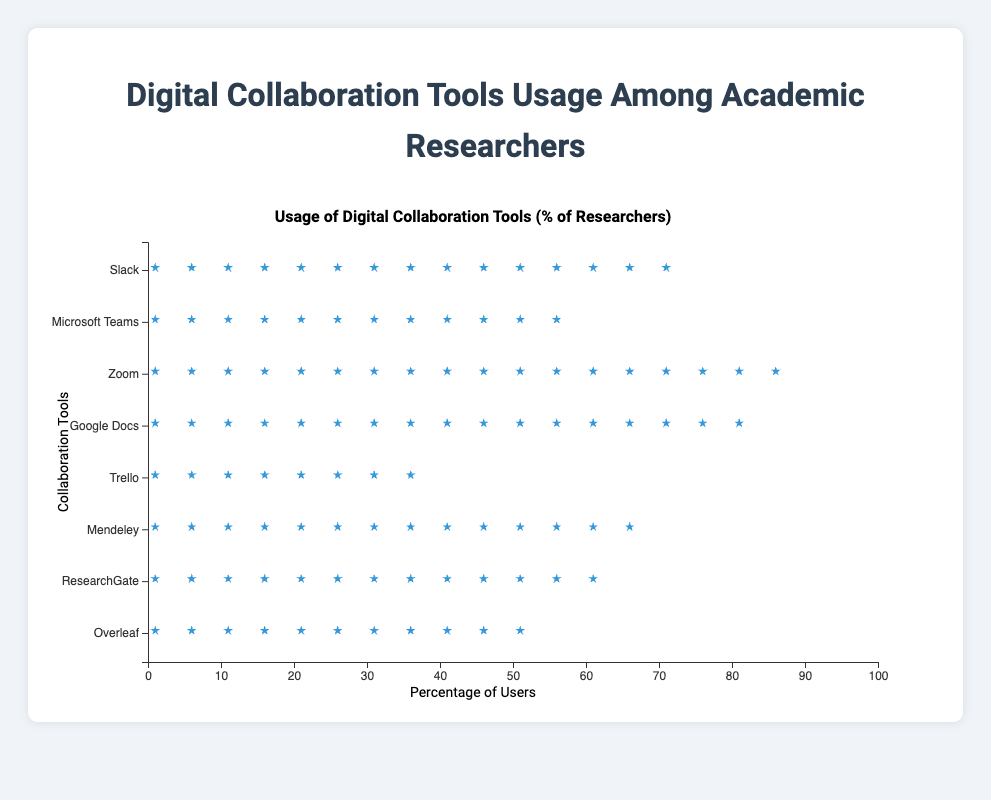What's the most used digital collaboration tool among academic researchers? To answer this, look for the tool with the highest number of icons or the longest row in the plot.
Answer: Zoom What's the least used digital collaboration tool among academic researchers? Identify the tool with the shortest row or the fewest number of icons.
Answer: Trello How many percentage points more researchers use Zoom compared to Trello? Zoom has 90% users and Trello has 40% users. The difference is calculated as 90 - 40.
Answer: 50 Which tool has more users, Microsoft Teams or ResearchGate? Compare the length of the rows or number of icons of both tools.
Answer: ResearchGate By how much does Mendeley usage lead Overleaf usage? Mendeley has 70% users while Overleaf has 55% users. Calculate the difference as 70 - 55.
Answer: 15 Which tools have a user base between 50% and 70%? Identify the tools whose rows fall between the 50% and 70% marks.
Answer: Microsoft Teams, Mendeley, ResearchGate, Overleaf What is the total percentage of users for Slack and Google Docs combined? Sum the user percentages of Slack (75%) and Google Docs (85%). The sum is 75 + 85.
Answer: 160 How does the usage of Google Docs compare to Zoom? Directly compare the lengths of the rows or number of icons.
Answer: Google Docs has slightly fewer users Which tool just surpasses the 50% user mark? Identify the tool whose row starts just after the midpoint on the x-axis.
Answer: Overleaf What is the average users' percentage of Slack, Microsoft Teams, and Trello? Sum the user percentages of these tools: 75% (Slack), 60% (Microsoft Teams), and 40% (Trello), then divide by 3. The calculation is (75 + 60 + 40) / 3.
Answer: 58.3 